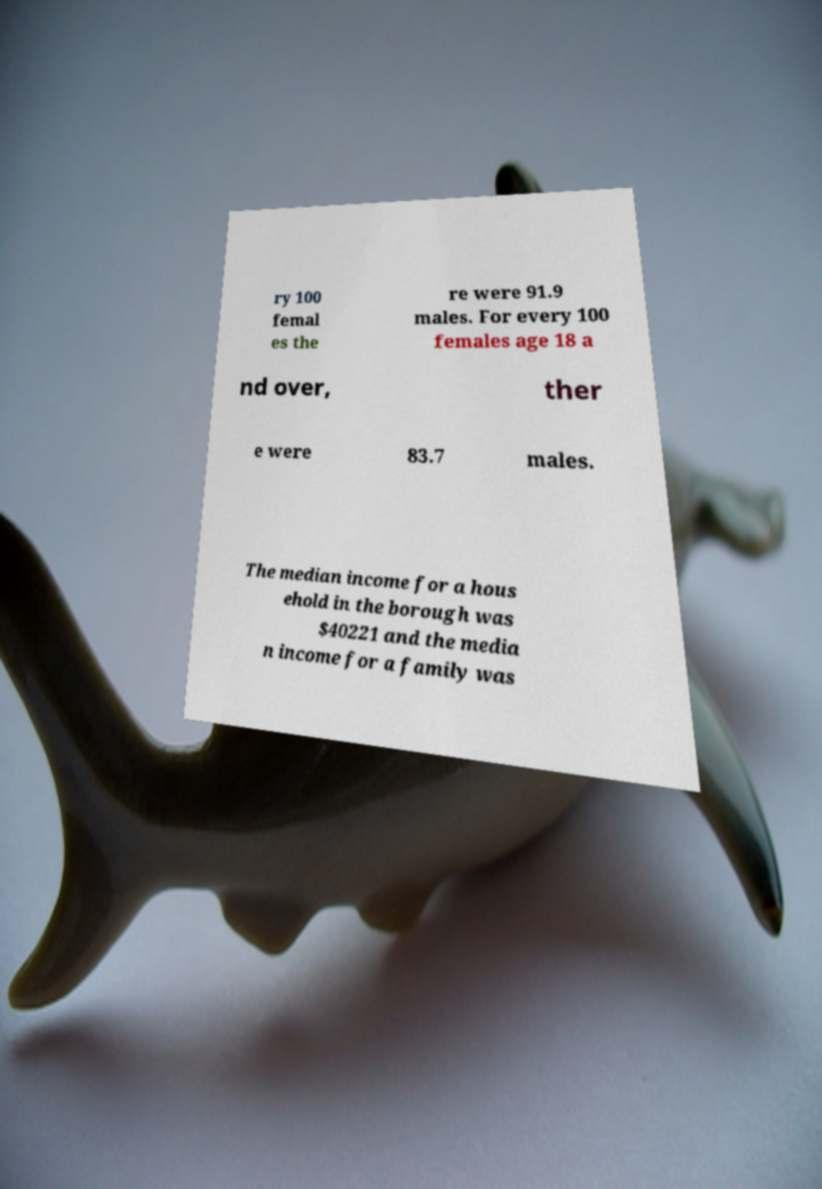Please read and relay the text visible in this image. What does it say? ry 100 femal es the re were 91.9 males. For every 100 females age 18 a nd over, ther e were 83.7 males. The median income for a hous ehold in the borough was $40221 and the media n income for a family was 